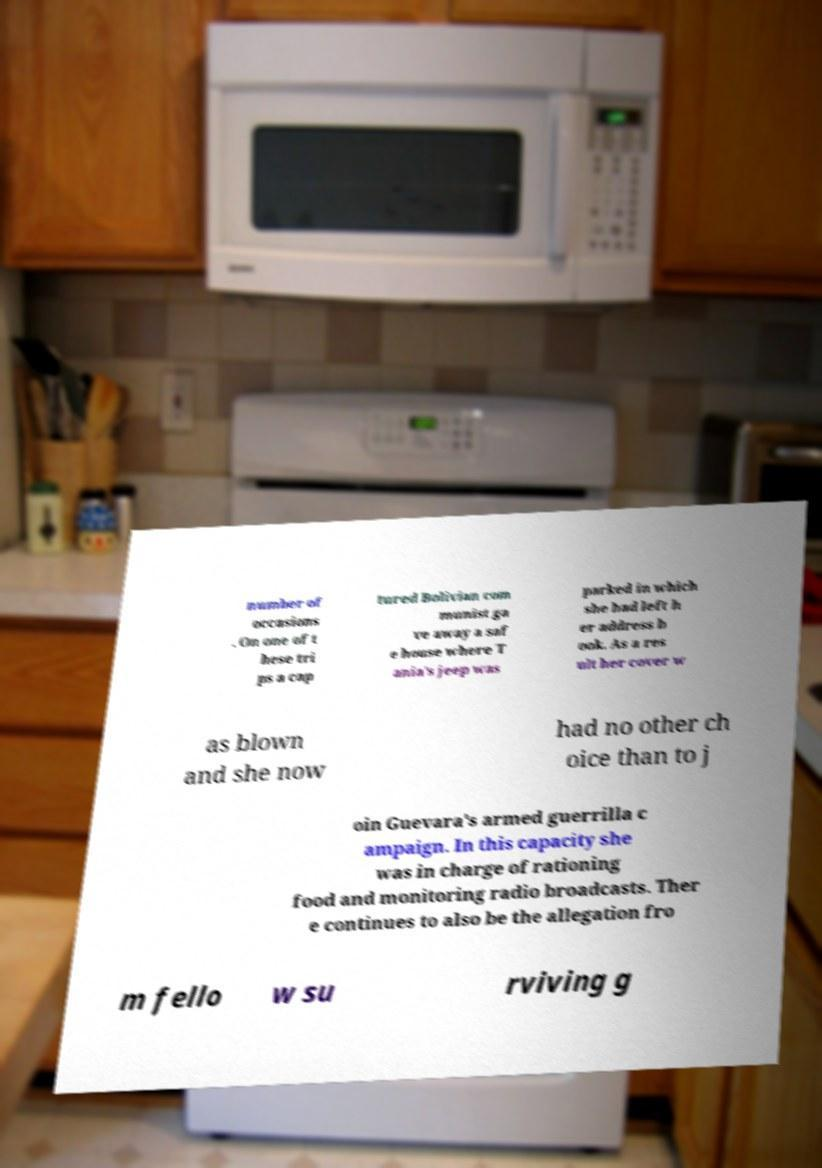There's text embedded in this image that I need extracted. Can you transcribe it verbatim? number of occasions . On one of t hese tri ps a cap tured Bolivian com munist ga ve away a saf e house where T ania's jeep was parked in which she had left h er address b ook. As a res ult her cover w as blown and she now had no other ch oice than to j oin Guevara's armed guerrilla c ampaign. In this capacity she was in charge of rationing food and monitoring radio broadcasts. Ther e continues to also be the allegation fro m fello w su rviving g 